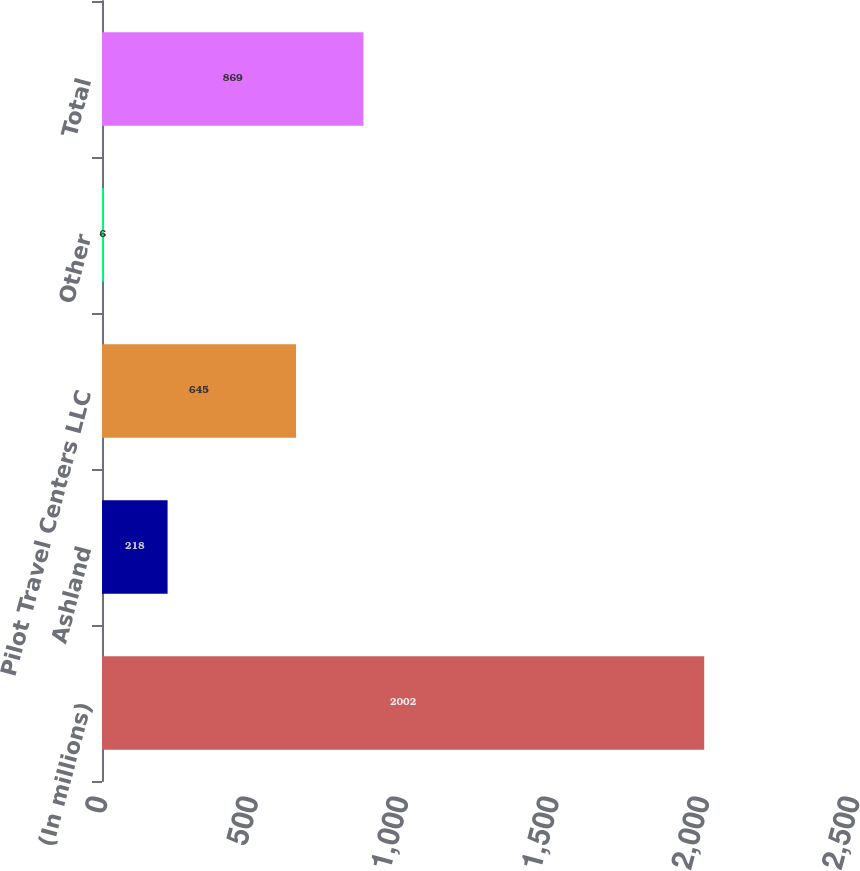Convert chart to OTSL. <chart><loc_0><loc_0><loc_500><loc_500><bar_chart><fcel>(In millions)<fcel>Ashland<fcel>Pilot Travel Centers LLC<fcel>Other<fcel>Total<nl><fcel>2002<fcel>218<fcel>645<fcel>6<fcel>869<nl></chart> 